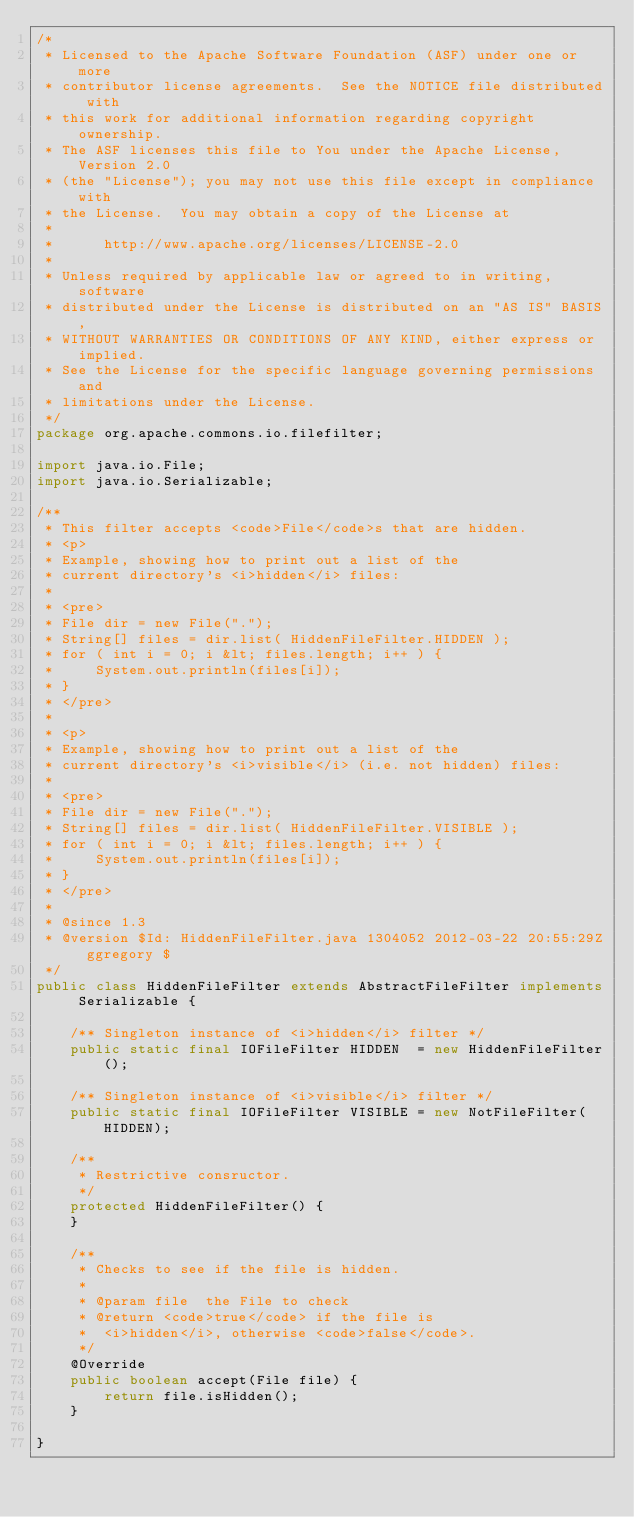Convert code to text. <code><loc_0><loc_0><loc_500><loc_500><_Java_>/*
 * Licensed to the Apache Software Foundation (ASF) under one or more
 * contributor license agreements.  See the NOTICE file distributed with
 * this work for additional information regarding copyright ownership.
 * The ASF licenses this file to You under the Apache License, Version 2.0
 * (the "License"); you may not use this file except in compliance with
 * the License.  You may obtain a copy of the License at
 * 
 *      http://www.apache.org/licenses/LICENSE-2.0
 * 
 * Unless required by applicable law or agreed to in writing, software
 * distributed under the License is distributed on an "AS IS" BASIS,
 * WITHOUT WARRANTIES OR CONDITIONS OF ANY KIND, either express or implied.
 * See the License for the specific language governing permissions and
 * limitations under the License.
 */
package org.apache.commons.io.filefilter;

import java.io.File;
import java.io.Serializable;

/**
 * This filter accepts <code>File</code>s that are hidden.
 * <p>
 * Example, showing how to print out a list of the
 * current directory's <i>hidden</i> files:
 *
 * <pre>
 * File dir = new File(".");
 * String[] files = dir.list( HiddenFileFilter.HIDDEN );
 * for ( int i = 0; i &lt; files.length; i++ ) {
 *     System.out.println(files[i]);
 * }
 * </pre>
 *
 * <p>
 * Example, showing how to print out a list of the
 * current directory's <i>visible</i> (i.e. not hidden) files:
 *
 * <pre>
 * File dir = new File(".");
 * String[] files = dir.list( HiddenFileFilter.VISIBLE );
 * for ( int i = 0; i &lt; files.length; i++ ) {
 *     System.out.println(files[i]);
 * }
 * </pre>
 *
 * @since 1.3
 * @version $Id: HiddenFileFilter.java 1304052 2012-03-22 20:55:29Z ggregory $
 */
public class HiddenFileFilter extends AbstractFileFilter implements Serializable {
    
    /** Singleton instance of <i>hidden</i> filter */
    public static final IOFileFilter HIDDEN  = new HiddenFileFilter();
    
    /** Singleton instance of <i>visible</i> filter */
    public static final IOFileFilter VISIBLE = new NotFileFilter(HIDDEN);
    
    /**
     * Restrictive consructor.
     */
    protected HiddenFileFilter() {
    }
    
    /**
     * Checks to see if the file is hidden.
     * 
     * @param file  the File to check
     * @return <code>true</code> if the file is
     *  <i>hidden</i>, otherwise <code>false</code>.
     */
    @Override
    public boolean accept(File file) {
        return file.isHidden();
    }
    
}
</code> 